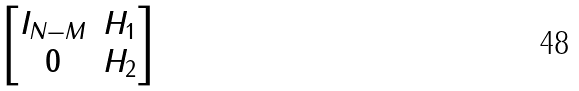<formula> <loc_0><loc_0><loc_500><loc_500>\begin{bmatrix} I _ { N - M } & H _ { 1 } \\ { 0 } & H _ { 2 } \end{bmatrix}</formula> 